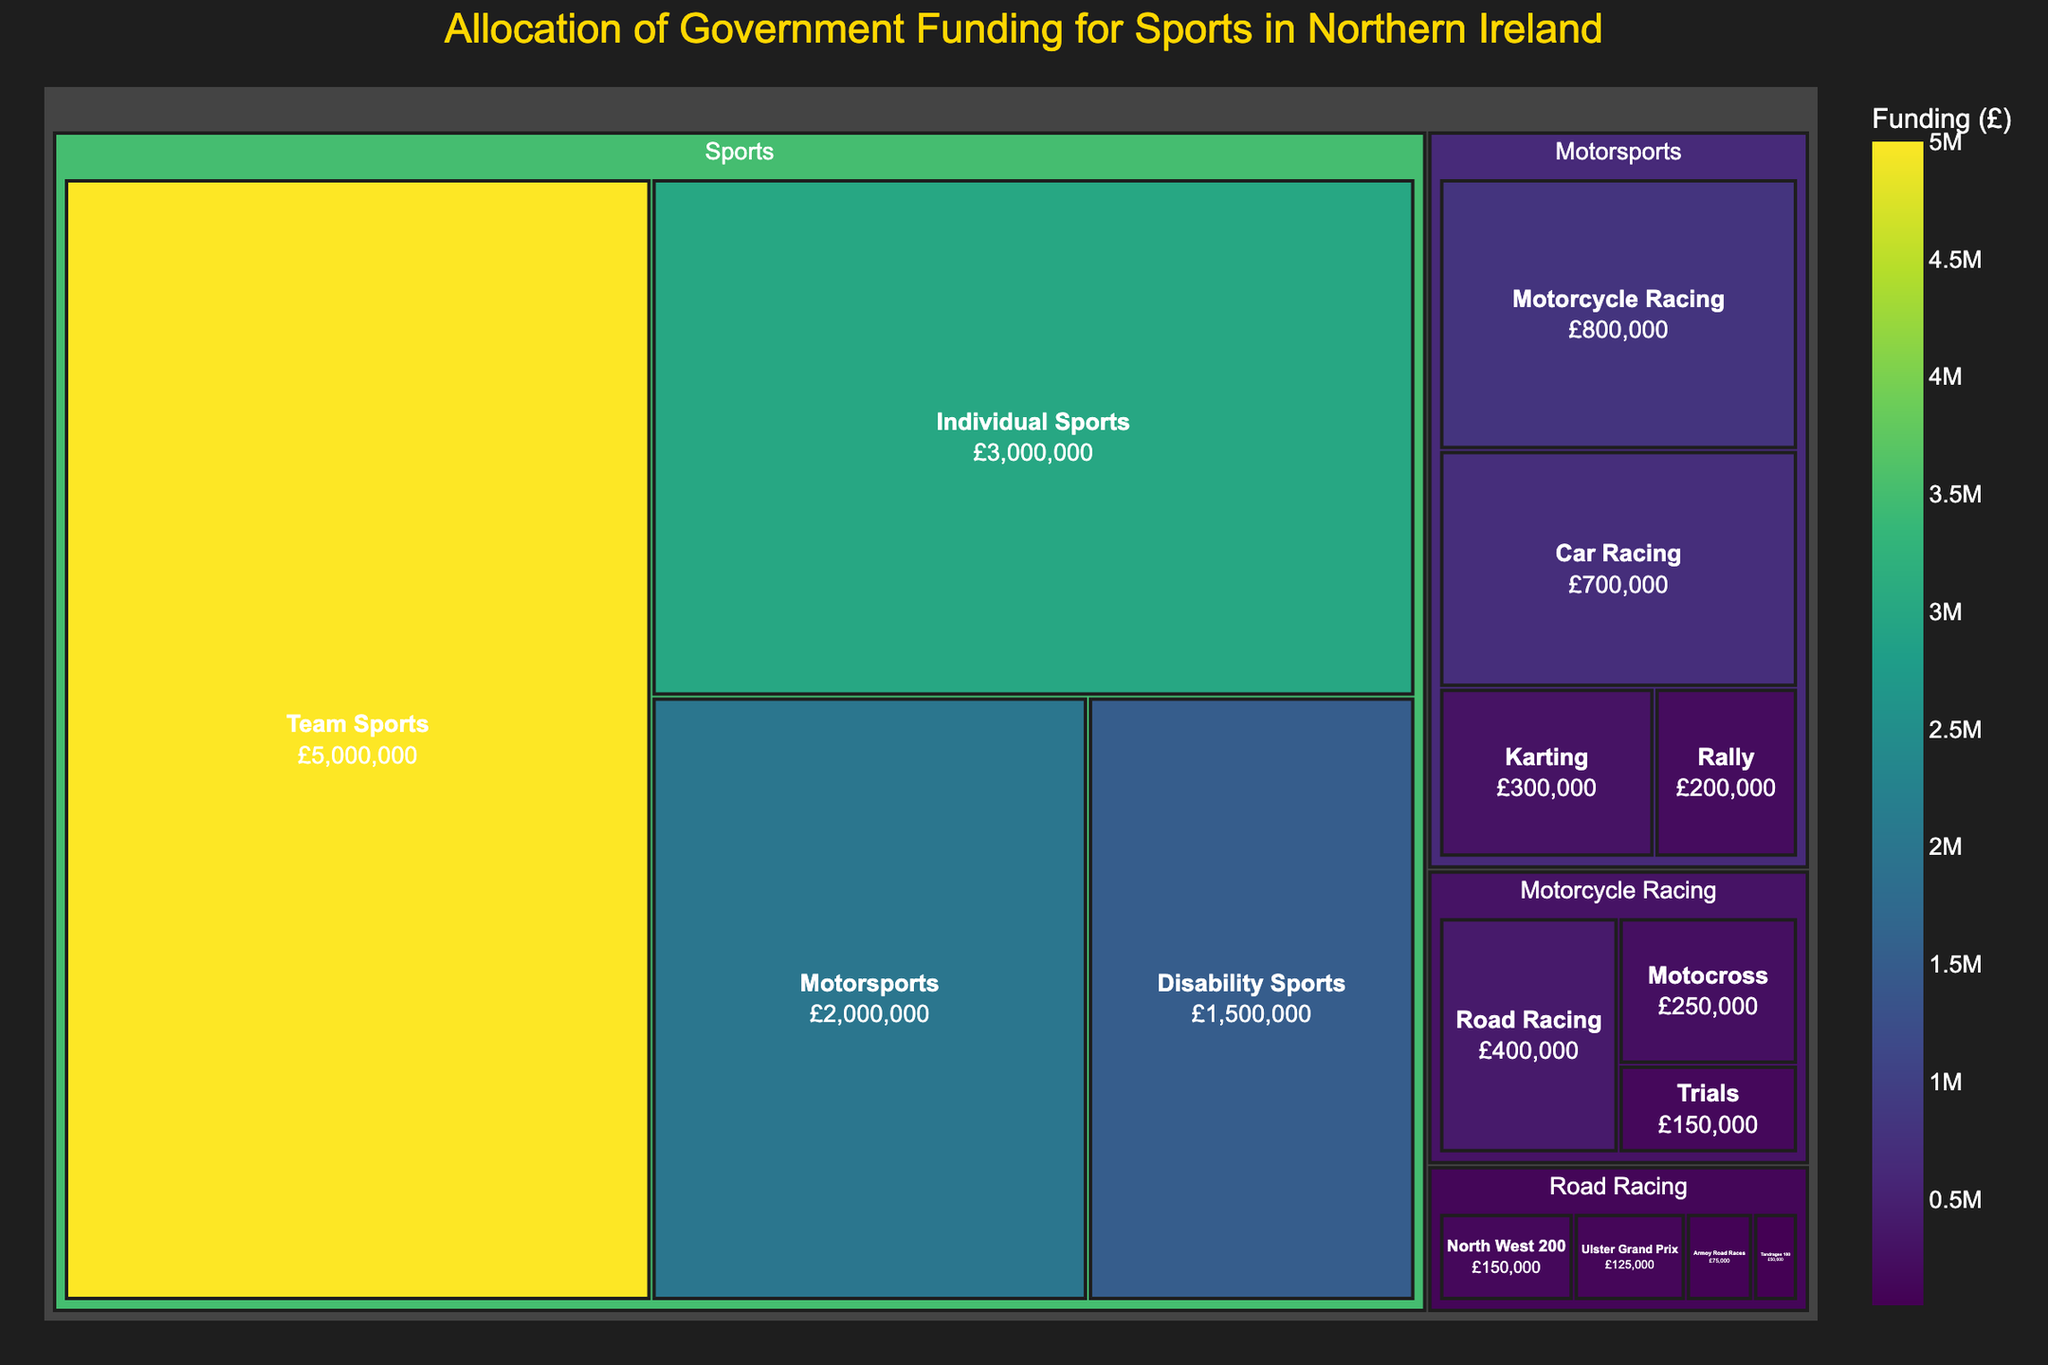What sport category receives the most government funding in Northern Ireland? The treemap shows the various categories of sports and their respective funding. The largest section by area represents the sport category receiving the most funding.
Answer: Team Sports How much government funding is allocated to motorcycle racing specifically? Locate the section labeled "Motorcycle Racing" in the treemap, and note the funding amount displayed on it.
Answer: £800,000 What is the total funding allocated to motorsports? To find the total motorsports funding, sum up the funding for Motorcycle Racing, Car Racing, Karting, and Rally.
Answer: £2,000,000 Which receives more funding, Road Racing or Karting? Compare the funding amounts displayed for the "Road Racing" and "Karting" sections in the treemap.
Answer: Road Racing What is the government funding allocation for the North West 200? Locate the "North West 200" under Road Racing and check the displayed funding amount.
Answer: £150,000 How does the funding for Motorcycle Racing compare to the total funding for Individual Sports? Compare the funding amounts shown for "Motorcycle Racing" and "Individual Sports" in the treemap.
Answer: Motorcycle Racing receives £800,000, while Individual Sports receive £3,000,000 What is the difference in funding between Team Sports and Individual Sports? Subtract the funding amount for Individual Sports from the funding amount for Team Sports.
Answer: £2,000,000 Which subcategory within Road Racing receives the least funding? Within the Road Racing section, locate the subcategory with the smallest displayed funding amount.
Answer: Tandragee 100 How much government funding is allocated to the Ulster Grand Prix? Find the section labeled "Ulster Grand Prix" under Road Racing and note the funding amount.
Answer: £125,000 Is the funding for Road Racing greater than the funding for Rally? Sum the funding for North West 200, Ulster Grand Prix, Armoy Road Races, and Tandragee 100 under Road Racing, and compare it to the funding for Rally.
Answer: Yes 